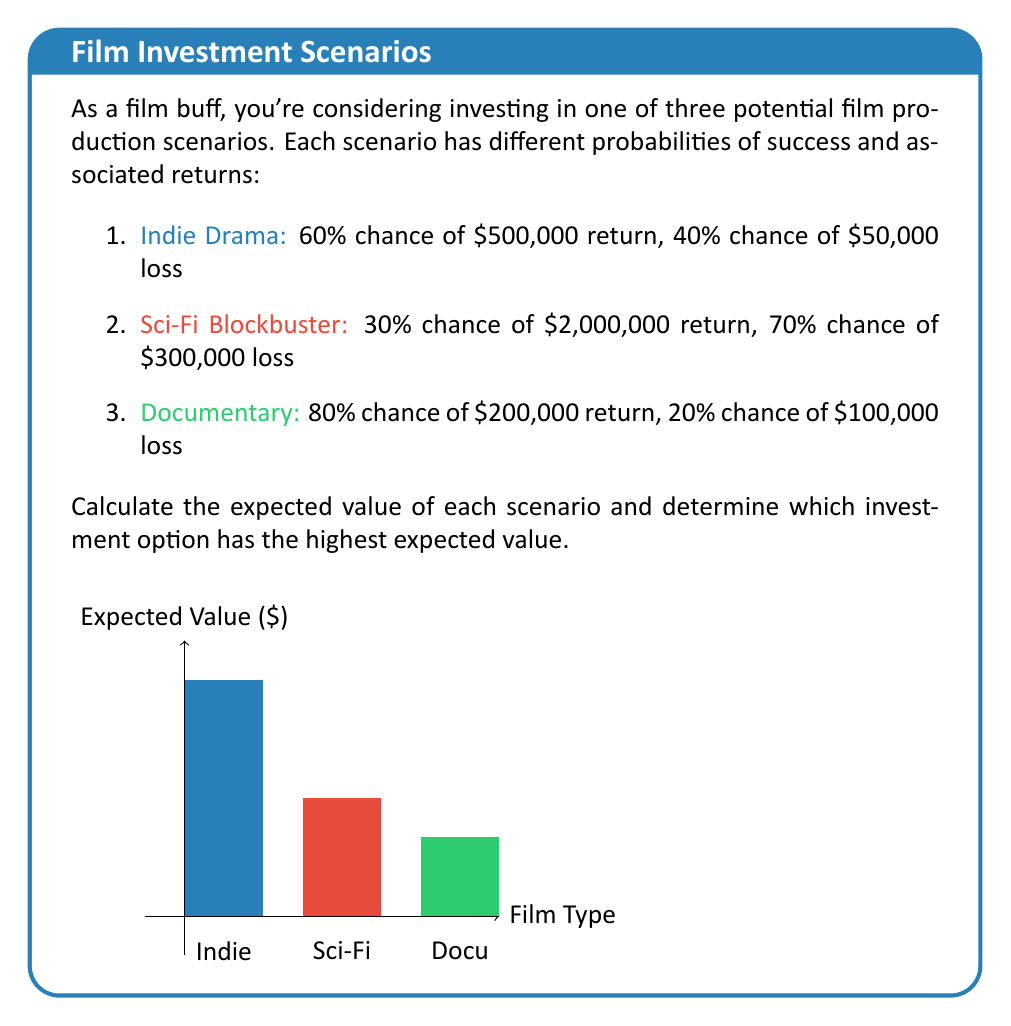What is the answer to this math problem? To solve this problem, we need to calculate the expected value for each scenario using the formula:

$$ E(X) = \sum_{i=1}^{n} p_i \cdot x_i $$

Where $p_i$ is the probability of each outcome and $x_i$ is the corresponding value.

1. Indie Drama:
   $E(X_1) = 0.60 \cdot \$500,000 + 0.40 \cdot (-\$50,000)$
   $E(X_1) = \$300,000 - \$20,000 = \$280,000$

2. Sci-Fi Blockbuster:
   $E(X_2) = 0.30 \cdot \$2,000,000 + 0.70 \cdot (-\$300,000)$
   $E(X_2) = \$600,000 - \$210,000 = \$390,000$

3. Documentary:
   $E(X_3) = 0.80 \cdot \$200,000 + 0.20 \cdot (-\$100,000)$
   $E(X_3) = \$160,000 - \$20,000 = \$140,000$

Comparing the expected values:
$E(X_2) > E(X_1) > E(X_3)$

Therefore, the Sci-Fi Blockbuster has the highest expected value at $390,000.
Answer: Sci-Fi Blockbuster, $390,000 